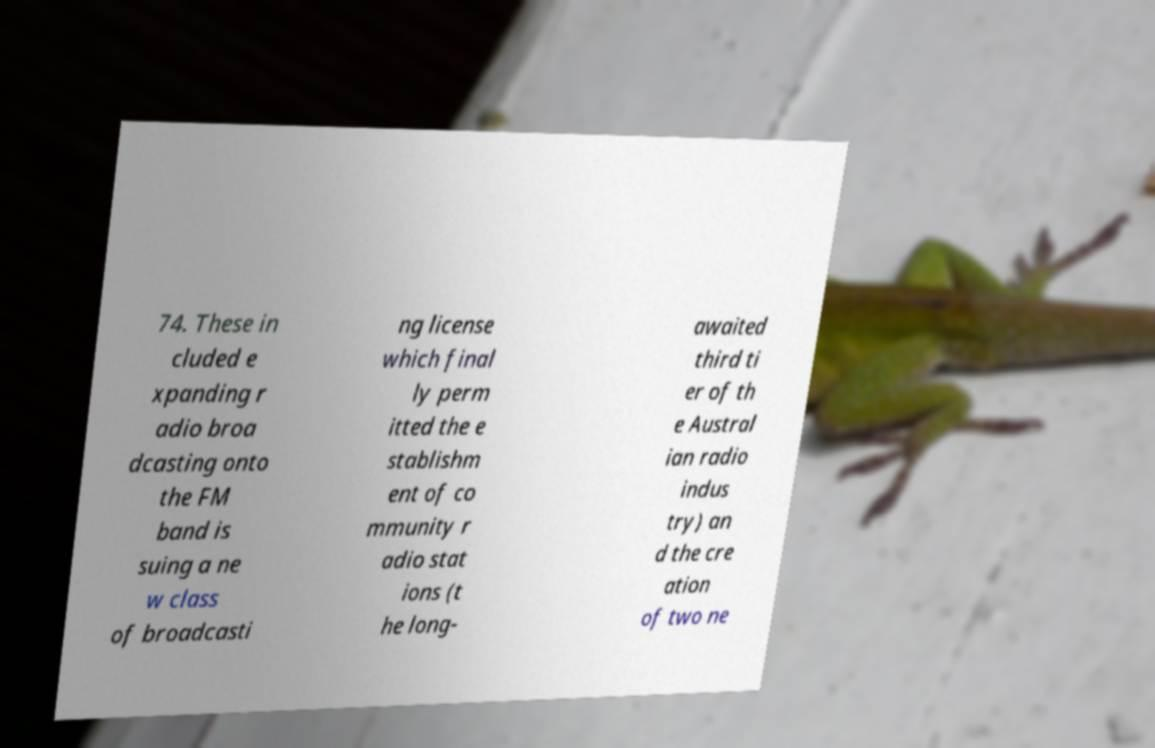For documentation purposes, I need the text within this image transcribed. Could you provide that? 74. These in cluded e xpanding r adio broa dcasting onto the FM band is suing a ne w class of broadcasti ng license which final ly perm itted the e stablishm ent of co mmunity r adio stat ions (t he long- awaited third ti er of th e Austral ian radio indus try) an d the cre ation of two ne 